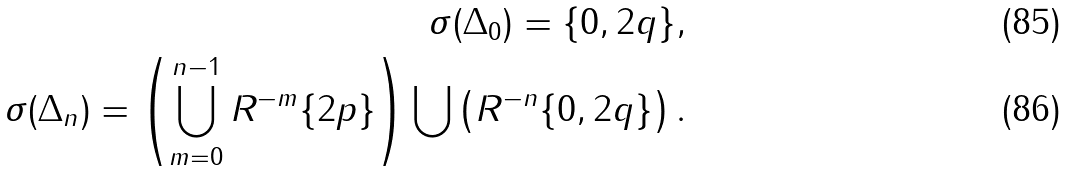Convert formula to latex. <formula><loc_0><loc_0><loc_500><loc_500>\sigma ( \Delta _ { 0 } ) = \{ 0 , 2 q \} , \\ \sigma ( \Delta _ { n } ) = \left ( \bigcup _ { m = 0 } ^ { n - 1 } R ^ { - m } \{ 2 p \} \right ) \bigcup \left ( R ^ { - n } \{ 0 , 2 q \} \right ) .</formula> 